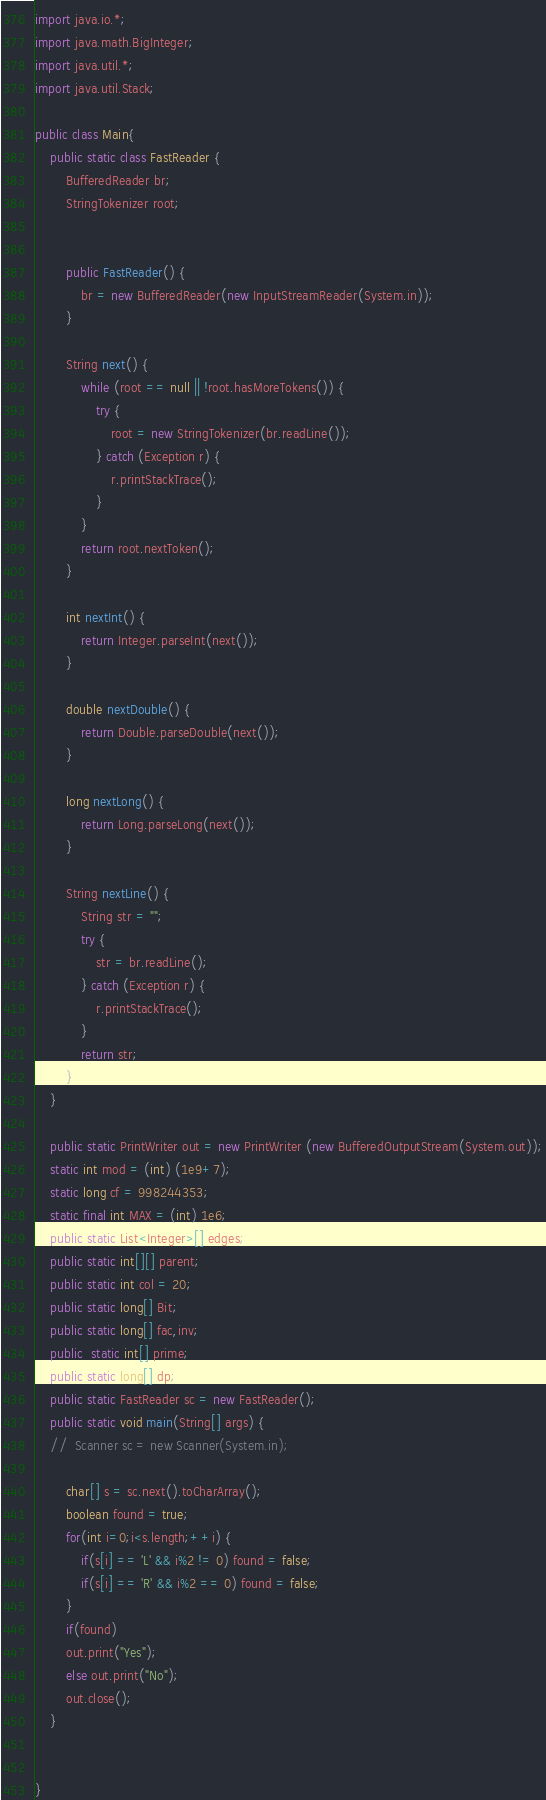<code> <loc_0><loc_0><loc_500><loc_500><_Java_>

import java.io.*;
import java.math.BigInteger;
import java.util.*;
import java.util.Stack;

public class Main{
	public static class FastReader {
		BufferedReader br;
		StringTokenizer root;
		
 
		public FastReader() {
			br = new BufferedReader(new InputStreamReader(System.in));
		}
 
		String next() {
			while (root == null || !root.hasMoreTokens()) {
				try {
					root = new StringTokenizer(br.readLine());
				} catch (Exception r) {
					r.printStackTrace();
				}
			}
			return root.nextToken();
		}
 
		int nextInt() {
			return Integer.parseInt(next());
		}
 
		double nextDouble() {
			return Double.parseDouble(next());
		}
 
		long nextLong() {
			return Long.parseLong(next());
		}
 
		String nextLine() {
			String str = "";
			try {
				str = br.readLine();
			} catch (Exception r) {
				r.printStackTrace();
			}
			return str;
		}
	}
	
	public static PrintWriter out = new PrintWriter (new BufferedOutputStream(System.out));
	static int mod = (int) (1e9+7);
	static long cf = 998244353;
    static final int MAX = (int) 1e6;
    public static List<Integer>[] edges;
    public static int[][] parent;
    public static int col = 20;
    public static long[] Bit;
    public static long[] fac,inv;
    public  static int[] prime; 
    public static long[] dp;
	public static FastReader sc = new FastReader();
	public static void main(String[] args) {
	//	Scanner sc = new Scanner(System.in);
 
		char[] s = sc.next().toCharArray();
		boolean found = true;
		for(int i=0;i<s.length;++i) {
			if(s[i] == 'L' && i%2 != 0) found = false;
			if(s[i] == 'R' && i%2 == 0) found = false;
		}
		if(found)
		out.print("Yes");
		else out.print("No");
		out.close();
	}
	
	
}</code> 